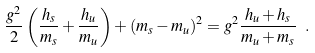Convert formula to latex. <formula><loc_0><loc_0><loc_500><loc_500>\frac { g ^ { 2 } } { 2 } \left ( \frac { h _ { s } } { m _ { s } } + \frac { h _ { u } } { m _ { u } } \right ) + ( m _ { s } - m _ { u } ) ^ { 2 } = g ^ { 2 } \frac { h _ { u } + h _ { s } } { m _ { u } + m _ { s } } \ .</formula> 